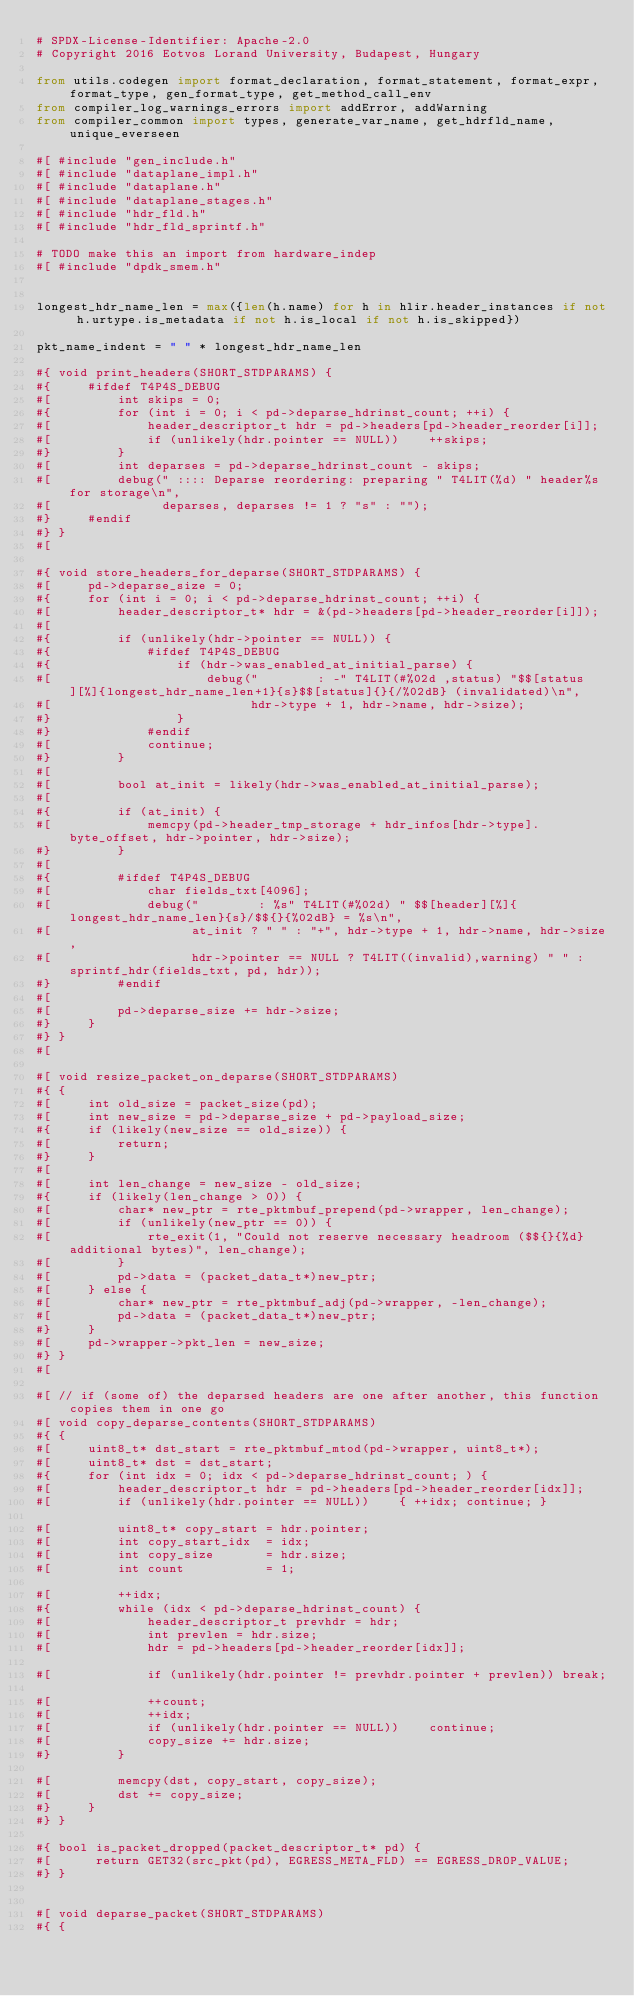<code> <loc_0><loc_0><loc_500><loc_500><_Python_># SPDX-License-Identifier: Apache-2.0
# Copyright 2016 Eotvos Lorand University, Budapest, Hungary

from utils.codegen import format_declaration, format_statement, format_expr, format_type, gen_format_type, get_method_call_env
from compiler_log_warnings_errors import addError, addWarning
from compiler_common import types, generate_var_name, get_hdrfld_name, unique_everseen

#[ #include "gen_include.h"
#[ #include "dataplane_impl.h"
#[ #include "dataplane.h"
#[ #include "dataplane_stages.h"
#[ #include "hdr_fld.h"
#[ #include "hdr_fld_sprintf.h"

# TODO make this an import from hardware_indep
#[ #include "dpdk_smem.h"


longest_hdr_name_len = max({len(h.name) for h in hlir.header_instances if not h.urtype.is_metadata if not h.is_local if not h.is_skipped})

pkt_name_indent = " " * longest_hdr_name_len

#{ void print_headers(SHORT_STDPARAMS) {
#{     #ifdef T4P4S_DEBUG
#[         int skips = 0;
#{         for (int i = 0; i < pd->deparse_hdrinst_count; ++i) {
#[             header_descriptor_t hdr = pd->headers[pd->header_reorder[i]];
#[             if (unlikely(hdr.pointer == NULL))    ++skips;
#}         }
#[         int deparses = pd->deparse_hdrinst_count - skips;
#[         debug(" :::: Deparse reordering: preparing " T4LIT(%d) " header%s for storage\n",
#[               deparses, deparses != 1 ? "s" : "");
#}     #endif
#} }
#[

#{ void store_headers_for_deparse(SHORT_STDPARAMS) {
#[     pd->deparse_size = 0;
#{     for (int i = 0; i < pd->deparse_hdrinst_count; ++i) {
#[         header_descriptor_t* hdr = &(pd->headers[pd->header_reorder[i]]);
#[
#{         if (unlikely(hdr->pointer == NULL)) {
#{             #ifdef T4P4S_DEBUG
#{                 if (hdr->was_enabled_at_initial_parse) {
#[                     debug("        : -" T4LIT(#%02d ,status) "$$[status][%]{longest_hdr_name_len+1}{s}$$[status]{}{/%02dB} (invalidated)\n",
#[                           hdr->type + 1, hdr->name, hdr->size);
#}                 }
#}             #endif
#[             continue;
#}         }
#[
#[         bool at_init = likely(hdr->was_enabled_at_initial_parse);
#[
#{         if (at_init) {
#[             memcpy(pd->header_tmp_storage + hdr_infos[hdr->type].byte_offset, hdr->pointer, hdr->size);
#}         }
#[
#{         #ifdef T4P4S_DEBUG
#[             char fields_txt[4096];
#[             debug("        : %s" T4LIT(#%02d) " $$[header][%]{longest_hdr_name_len}{s}/$${}{%02dB} = %s\n",
#[                   at_init ? " " : "+", hdr->type + 1, hdr->name, hdr->size,
#[                   hdr->pointer == NULL ? T4LIT((invalid),warning) " " : sprintf_hdr(fields_txt, pd, hdr));
#}         #endif
#[
#[         pd->deparse_size += hdr->size;
#}     }
#} }
#[

#[ void resize_packet_on_deparse(SHORT_STDPARAMS)
#{ {
#[     int old_size = packet_size(pd);
#[     int new_size = pd->deparse_size + pd->payload_size;
#{     if (likely(new_size == old_size)) {
#[         return;
#}     }
#[
#[     int len_change = new_size - old_size;
#{     if (likely(len_change > 0)) {
#[         char* new_ptr = rte_pktmbuf_prepend(pd->wrapper, len_change);
#[         if (unlikely(new_ptr == 0)) {
#[             rte_exit(1, "Could not reserve necessary headroom ($${}{%d} additional bytes)", len_change);
#[         }
#[         pd->data = (packet_data_t*)new_ptr;
#[     } else {
#[         char* new_ptr = rte_pktmbuf_adj(pd->wrapper, -len_change);
#[         pd->data = (packet_data_t*)new_ptr;
#}     }
#[     pd->wrapper->pkt_len = new_size;
#} }
#[

#[ // if (some of) the deparsed headers are one after another, this function copies them in one go
#[ void copy_deparse_contents(SHORT_STDPARAMS)
#{ {
#[     uint8_t* dst_start = rte_pktmbuf_mtod(pd->wrapper, uint8_t*);
#[     uint8_t* dst = dst_start;
#{     for (int idx = 0; idx < pd->deparse_hdrinst_count; ) {
#[         header_descriptor_t hdr = pd->headers[pd->header_reorder[idx]];
#[         if (unlikely(hdr.pointer == NULL))    { ++idx; continue; }

#[         uint8_t* copy_start = hdr.pointer;
#[         int copy_start_idx  = idx;
#[         int copy_size       = hdr.size;
#[         int count           = 1;

#[         ++idx;
#{         while (idx < pd->deparse_hdrinst_count) {
#[             header_descriptor_t prevhdr = hdr;
#[             int prevlen = hdr.size;
#[             hdr = pd->headers[pd->header_reorder[idx]];

#[             if (unlikely(hdr.pointer != prevhdr.pointer + prevlen)) break;

#[             ++count;
#[             ++idx;
#[             if (unlikely(hdr.pointer == NULL))    continue;
#[             copy_size += hdr.size;
#}         }

#[         memcpy(dst, copy_start, copy_size);
#[         dst += copy_size;
#}     }
#} }

#{ bool is_packet_dropped(packet_descriptor_t* pd) {
#[      return GET32(src_pkt(pd), EGRESS_META_FLD) == EGRESS_DROP_VALUE;
#} }


#[ void deparse_packet(SHORT_STDPARAMS)
#{ {</code> 